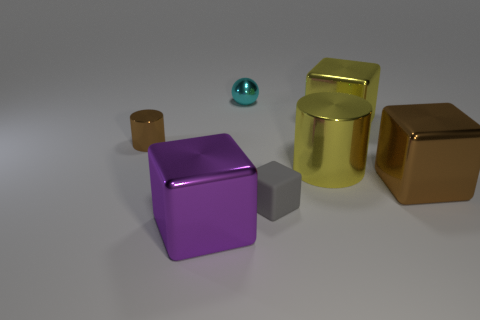What is the small thing that is both in front of the cyan sphere and right of the tiny cylinder made of?
Your answer should be very brief. Rubber. What number of other things are the same color as the small cube?
Give a very brief answer. 0. There is a brown metal thing behind the large brown metallic object; is it the same size as the ball that is behind the brown cylinder?
Your response must be concise. Yes. Is the number of purple objects on the left side of the tiny brown object the same as the number of cyan spheres that are behind the cyan sphere?
Give a very brief answer. Yes. Are there any other things that have the same material as the tiny block?
Your response must be concise. No. Does the shiny sphere have the same size as the cylinder that is to the left of the tiny metal ball?
Offer a terse response. Yes. What is the material of the yellow thing that is in front of the tiny brown cylinder behind the purple thing?
Ensure brevity in your answer.  Metal. Are there an equal number of matte blocks behind the purple cube and gray rubber blocks?
Your answer should be very brief. Yes. There is a cube that is both left of the yellow metallic block and right of the purple metal object; what size is it?
Your answer should be very brief. Small. The small metal object that is right of the big thing on the left side of the matte cube is what color?
Offer a terse response. Cyan. 